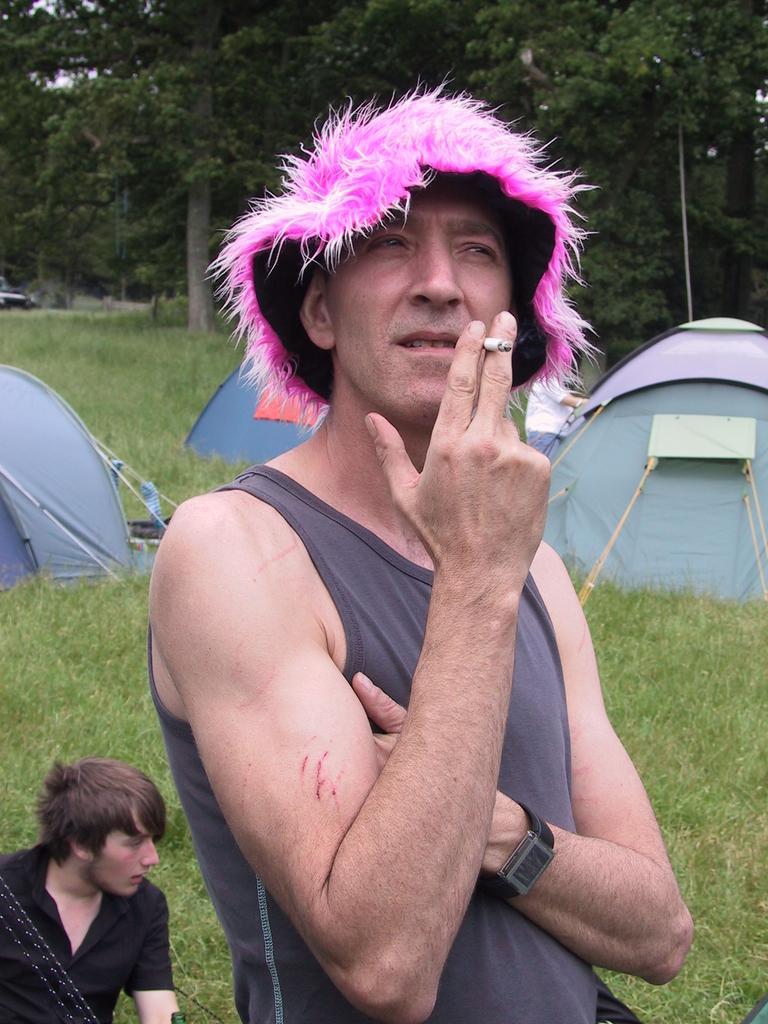In one or two sentences, can you explain what this image depicts? In this picture, we can see a few people, among them a person with a hat is smoking, and we can see the ground with grass, tents, trees and some object on the left side of the picture. 